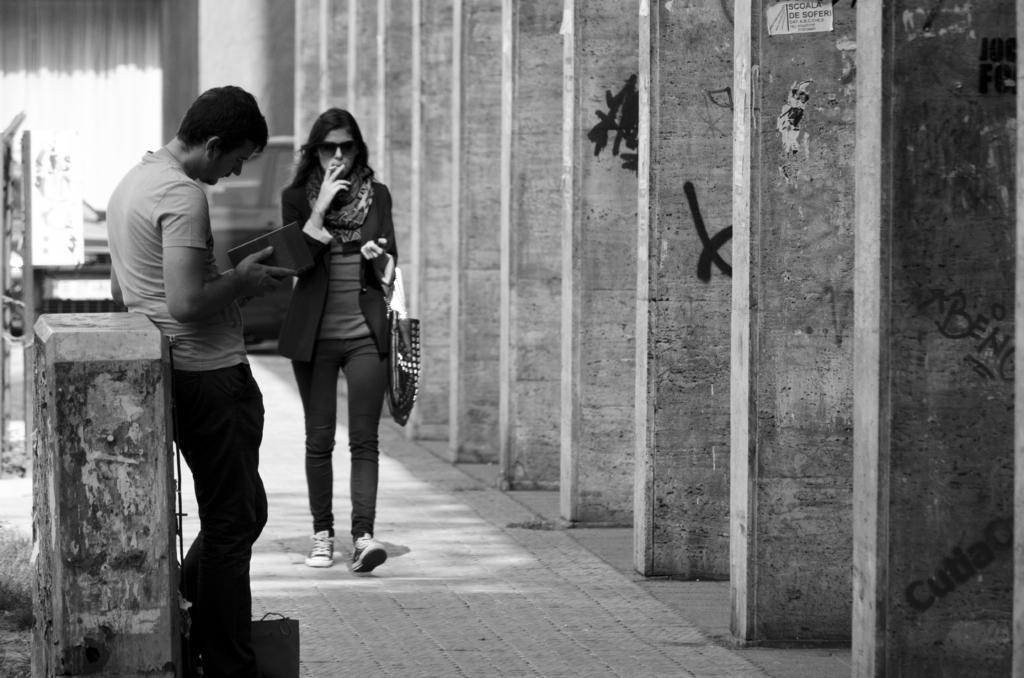Please provide a concise description of this image. In this image, we can see people and one of them is holding a book and the other is wearing a bag and glasses and holding a cigarette. In the background, we can see a poster on the wall and there is graffiti. At the bottom, there is a road. 